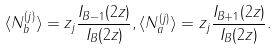<formula> <loc_0><loc_0><loc_500><loc_500>\langle N _ { b } ^ { ( j ) } \rangle = z _ { j } \frac { I _ { B - 1 } ( 2 z ) } { I _ { B } ( 2 z ) } , \langle N _ { a } ^ { ( j ) } \rangle = z _ { j } \frac { I _ { B + 1 } ( 2 z ) } { I _ { B } ( 2 z ) } .</formula> 